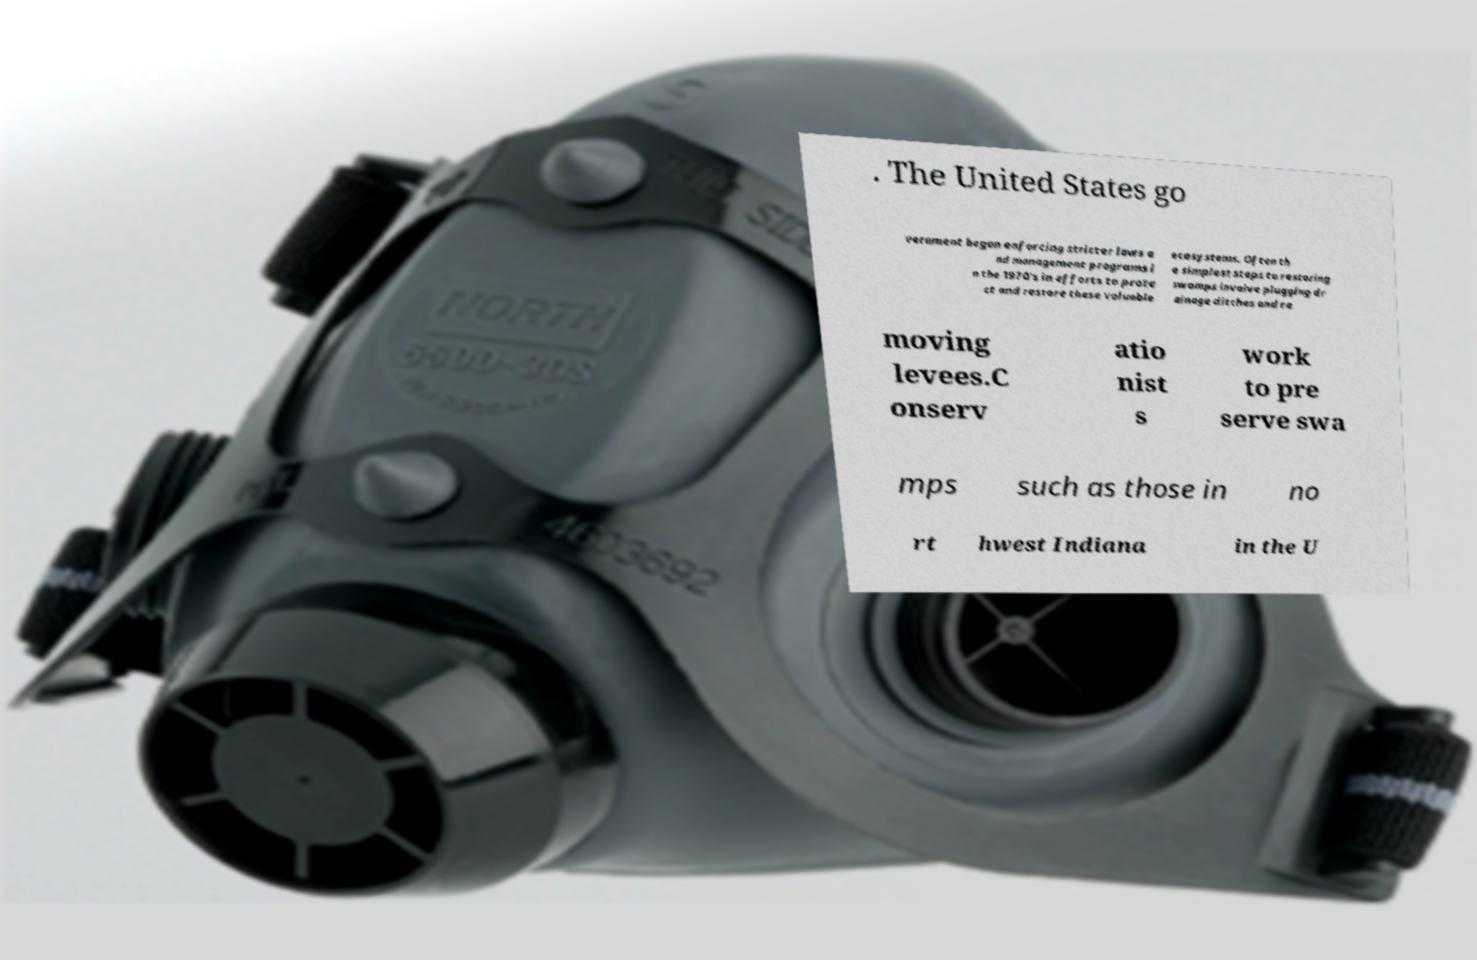Could you extract and type out the text from this image? . The United States go vernment began enforcing stricter laws a nd management programs i n the 1970's in efforts to prote ct and restore these valuable ecosystems. Often th e simplest steps to restoring swamps involve plugging dr ainage ditches and re moving levees.C onserv atio nist s work to pre serve swa mps such as those in no rt hwest Indiana in the U 